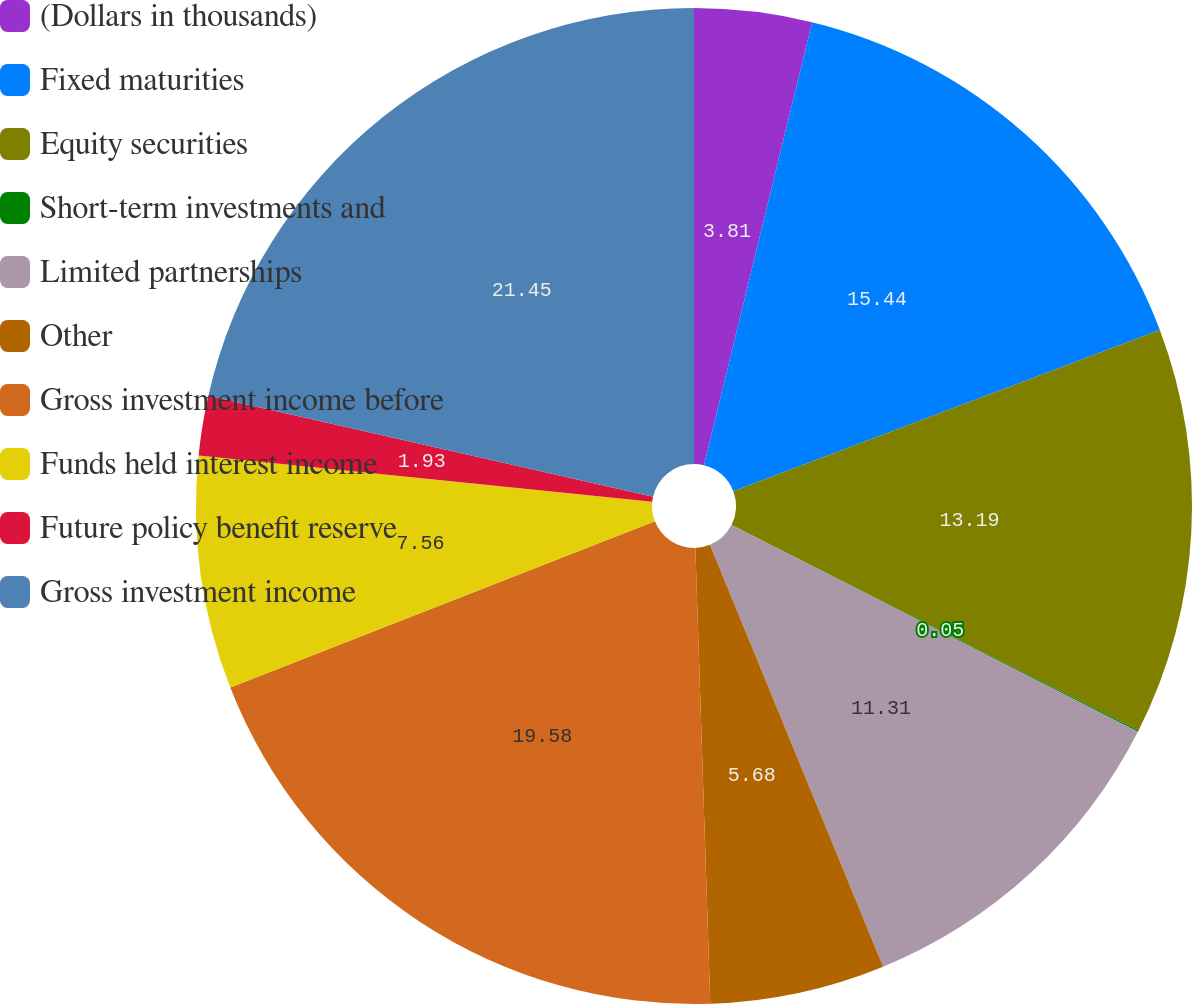Convert chart. <chart><loc_0><loc_0><loc_500><loc_500><pie_chart><fcel>(Dollars in thousands)<fcel>Fixed maturities<fcel>Equity securities<fcel>Short-term investments and<fcel>Limited partnerships<fcel>Other<fcel>Gross investment income before<fcel>Funds held interest income<fcel>Future policy benefit reserve<fcel>Gross investment income<nl><fcel>3.81%<fcel>15.44%<fcel>13.19%<fcel>0.05%<fcel>11.31%<fcel>5.68%<fcel>19.58%<fcel>7.56%<fcel>1.93%<fcel>21.45%<nl></chart> 